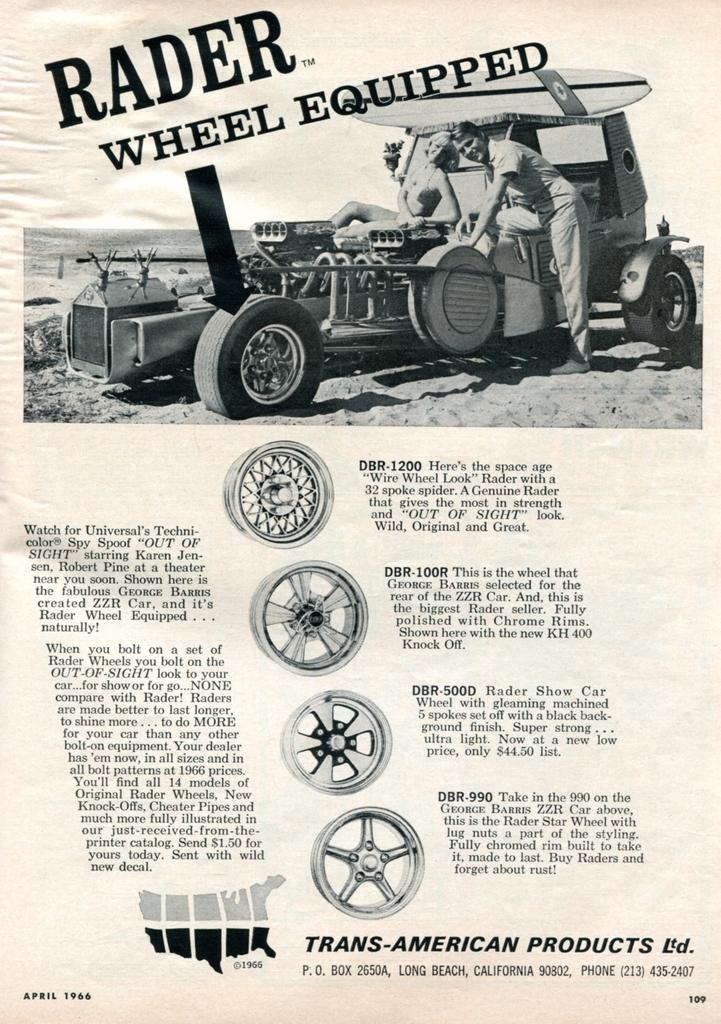How many people are in the image? There is a man and a woman in the image, making a total of two people. What type of vehicle is in the image? The vehicle in the image has wheels, but the specific type is not mentioned. Can you describe the text visible in the image? There is some text visible in the image, but the content or language of the text is not mentioned. What is the purpose of the numbers present in the image? The purpose of the numbers present in the image is not mentioned, but they are visible. What color of paint is used to cover the substance in the image? There is no substance or paint present in the image; it features a man, a woman, a vehicle, text, and numbers. 